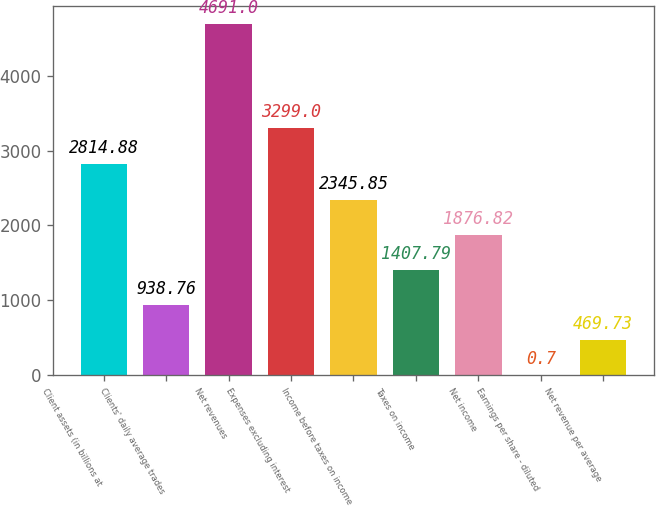Convert chart. <chart><loc_0><loc_0><loc_500><loc_500><bar_chart><fcel>Client assets (in billions at<fcel>Clients' daily average trades<fcel>Net revenues<fcel>Expenses excluding interest<fcel>Income before taxes on income<fcel>Taxes on income<fcel>Net income<fcel>Earnings per share - diluted<fcel>Net revenue per average<nl><fcel>2814.88<fcel>938.76<fcel>4691<fcel>3299<fcel>2345.85<fcel>1407.79<fcel>1876.82<fcel>0.7<fcel>469.73<nl></chart> 